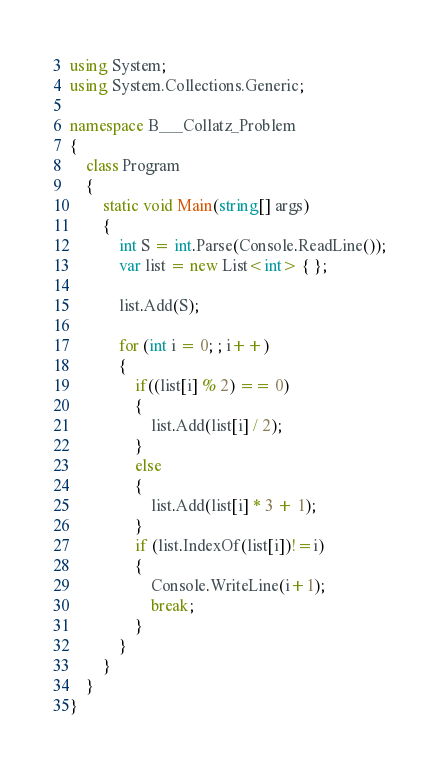Convert code to text. <code><loc_0><loc_0><loc_500><loc_500><_C#_>using System;
using System.Collections.Generic;

namespace B___Collatz_Problem
{
    class Program
    {
        static void Main(string[] args)
        {
            int S = int.Parse(Console.ReadLine());
            var list = new List<int> { };

            list.Add(S);

            for (int i = 0; ; i++)
            {
                if((list[i] % 2) == 0)
                {
                    list.Add(list[i] / 2);
                }
                else
                {
                    list.Add(list[i] * 3 + 1);
                }
                if (list.IndexOf(list[i])!=i)
                {
                    Console.WriteLine(i+1);
                    break;
                }
            }
        }
    }
}</code> 